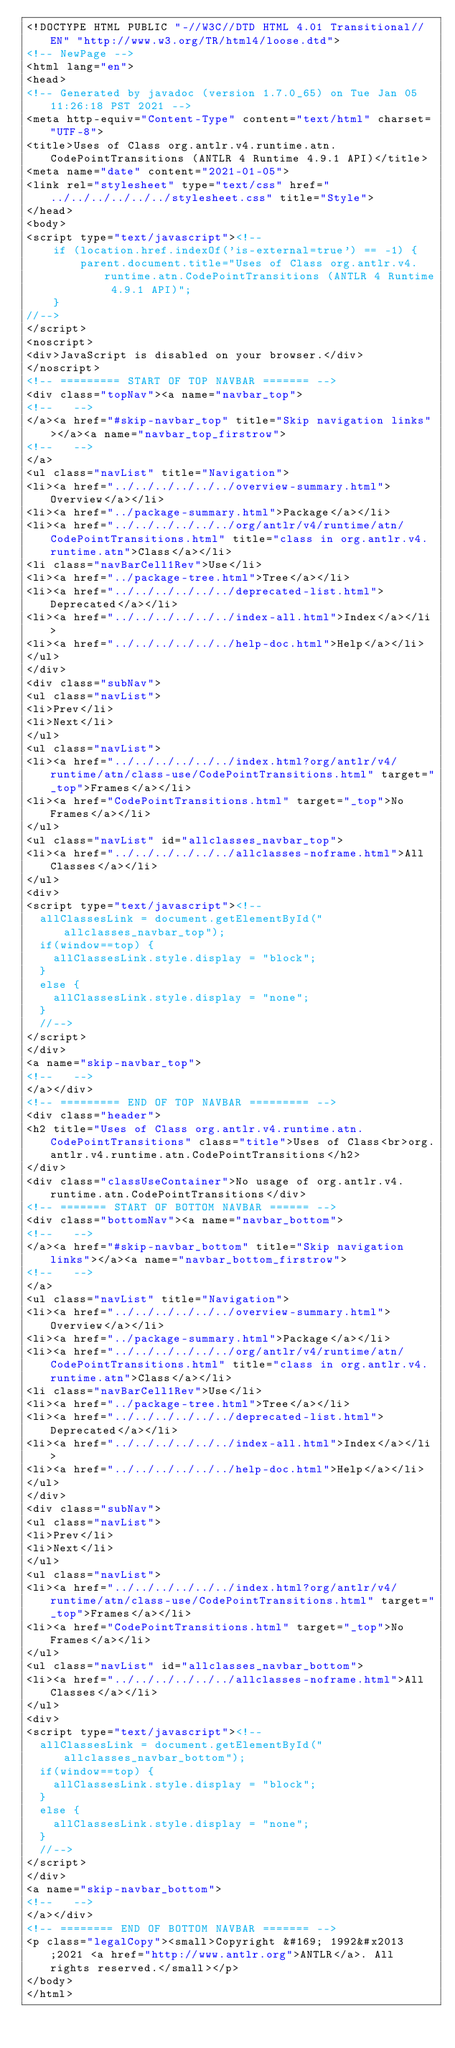<code> <loc_0><loc_0><loc_500><loc_500><_HTML_><!DOCTYPE HTML PUBLIC "-//W3C//DTD HTML 4.01 Transitional//EN" "http://www.w3.org/TR/html4/loose.dtd">
<!-- NewPage -->
<html lang="en">
<head>
<!-- Generated by javadoc (version 1.7.0_65) on Tue Jan 05 11:26:18 PST 2021 -->
<meta http-equiv="Content-Type" content="text/html" charset="UTF-8">
<title>Uses of Class org.antlr.v4.runtime.atn.CodePointTransitions (ANTLR 4 Runtime 4.9.1 API)</title>
<meta name="date" content="2021-01-05">
<link rel="stylesheet" type="text/css" href="../../../../../../stylesheet.css" title="Style">
</head>
<body>
<script type="text/javascript"><!--
    if (location.href.indexOf('is-external=true') == -1) {
        parent.document.title="Uses of Class org.antlr.v4.runtime.atn.CodePointTransitions (ANTLR 4 Runtime 4.9.1 API)";
    }
//-->
</script>
<noscript>
<div>JavaScript is disabled on your browser.</div>
</noscript>
<!-- ========= START OF TOP NAVBAR ======= -->
<div class="topNav"><a name="navbar_top">
<!--   -->
</a><a href="#skip-navbar_top" title="Skip navigation links"></a><a name="navbar_top_firstrow">
<!--   -->
</a>
<ul class="navList" title="Navigation">
<li><a href="../../../../../../overview-summary.html">Overview</a></li>
<li><a href="../package-summary.html">Package</a></li>
<li><a href="../../../../../../org/antlr/v4/runtime/atn/CodePointTransitions.html" title="class in org.antlr.v4.runtime.atn">Class</a></li>
<li class="navBarCell1Rev">Use</li>
<li><a href="../package-tree.html">Tree</a></li>
<li><a href="../../../../../../deprecated-list.html">Deprecated</a></li>
<li><a href="../../../../../../index-all.html">Index</a></li>
<li><a href="../../../../../../help-doc.html">Help</a></li>
</ul>
</div>
<div class="subNav">
<ul class="navList">
<li>Prev</li>
<li>Next</li>
</ul>
<ul class="navList">
<li><a href="../../../../../../index.html?org/antlr/v4/runtime/atn/class-use/CodePointTransitions.html" target="_top">Frames</a></li>
<li><a href="CodePointTransitions.html" target="_top">No Frames</a></li>
</ul>
<ul class="navList" id="allclasses_navbar_top">
<li><a href="../../../../../../allclasses-noframe.html">All Classes</a></li>
</ul>
<div>
<script type="text/javascript"><!--
  allClassesLink = document.getElementById("allclasses_navbar_top");
  if(window==top) {
    allClassesLink.style.display = "block";
  }
  else {
    allClassesLink.style.display = "none";
  }
  //-->
</script>
</div>
<a name="skip-navbar_top">
<!--   -->
</a></div>
<!-- ========= END OF TOP NAVBAR ========= -->
<div class="header">
<h2 title="Uses of Class org.antlr.v4.runtime.atn.CodePointTransitions" class="title">Uses of Class<br>org.antlr.v4.runtime.atn.CodePointTransitions</h2>
</div>
<div class="classUseContainer">No usage of org.antlr.v4.runtime.atn.CodePointTransitions</div>
<!-- ======= START OF BOTTOM NAVBAR ====== -->
<div class="bottomNav"><a name="navbar_bottom">
<!--   -->
</a><a href="#skip-navbar_bottom" title="Skip navigation links"></a><a name="navbar_bottom_firstrow">
<!--   -->
</a>
<ul class="navList" title="Navigation">
<li><a href="../../../../../../overview-summary.html">Overview</a></li>
<li><a href="../package-summary.html">Package</a></li>
<li><a href="../../../../../../org/antlr/v4/runtime/atn/CodePointTransitions.html" title="class in org.antlr.v4.runtime.atn">Class</a></li>
<li class="navBarCell1Rev">Use</li>
<li><a href="../package-tree.html">Tree</a></li>
<li><a href="../../../../../../deprecated-list.html">Deprecated</a></li>
<li><a href="../../../../../../index-all.html">Index</a></li>
<li><a href="../../../../../../help-doc.html">Help</a></li>
</ul>
</div>
<div class="subNav">
<ul class="navList">
<li>Prev</li>
<li>Next</li>
</ul>
<ul class="navList">
<li><a href="../../../../../../index.html?org/antlr/v4/runtime/atn/class-use/CodePointTransitions.html" target="_top">Frames</a></li>
<li><a href="CodePointTransitions.html" target="_top">No Frames</a></li>
</ul>
<ul class="navList" id="allclasses_navbar_bottom">
<li><a href="../../../../../../allclasses-noframe.html">All Classes</a></li>
</ul>
<div>
<script type="text/javascript"><!--
  allClassesLink = document.getElementById("allclasses_navbar_bottom");
  if(window==top) {
    allClassesLink.style.display = "block";
  }
  else {
    allClassesLink.style.display = "none";
  }
  //-->
</script>
</div>
<a name="skip-navbar_bottom">
<!--   -->
</a></div>
<!-- ======== END OF BOTTOM NAVBAR ======= -->
<p class="legalCopy"><small>Copyright &#169; 1992&#x2013;2021 <a href="http://www.antlr.org">ANTLR</a>. All rights reserved.</small></p>
</body>
</html>
</code> 